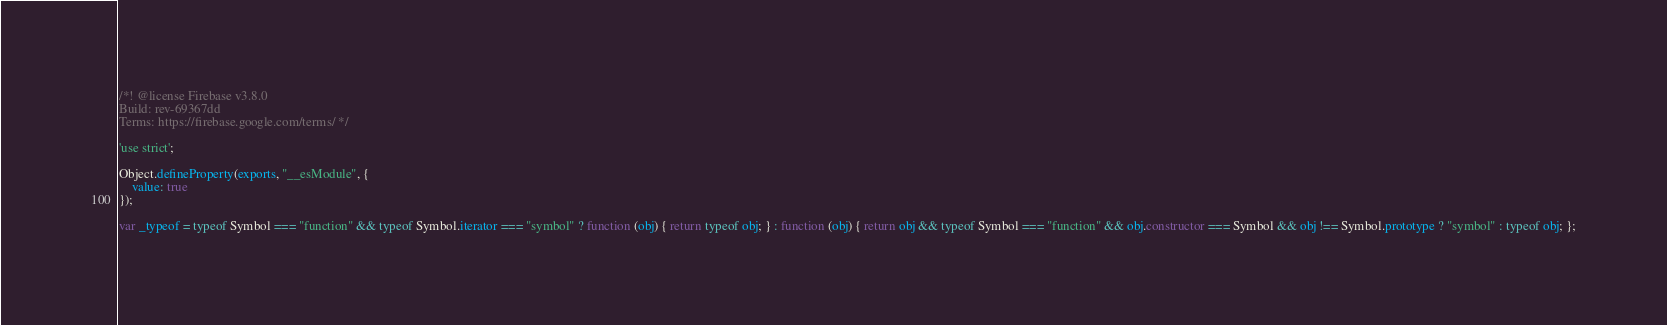<code> <loc_0><loc_0><loc_500><loc_500><_JavaScript_>/*! @license Firebase v3.8.0
Build: rev-69367dd
Terms: https://firebase.google.com/terms/ */

'use strict';

Object.defineProperty(exports, "__esModule", {
    value: true
});

var _typeof = typeof Symbol === "function" && typeof Symbol.iterator === "symbol" ? function (obj) { return typeof obj; } : function (obj) { return obj && typeof Symbol === "function" && obj.constructor === Symbol && obj !== Symbol.prototype ? "symbol" : typeof obj; };
</code> 